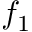<formula> <loc_0><loc_0><loc_500><loc_500>f _ { 1 }</formula> 